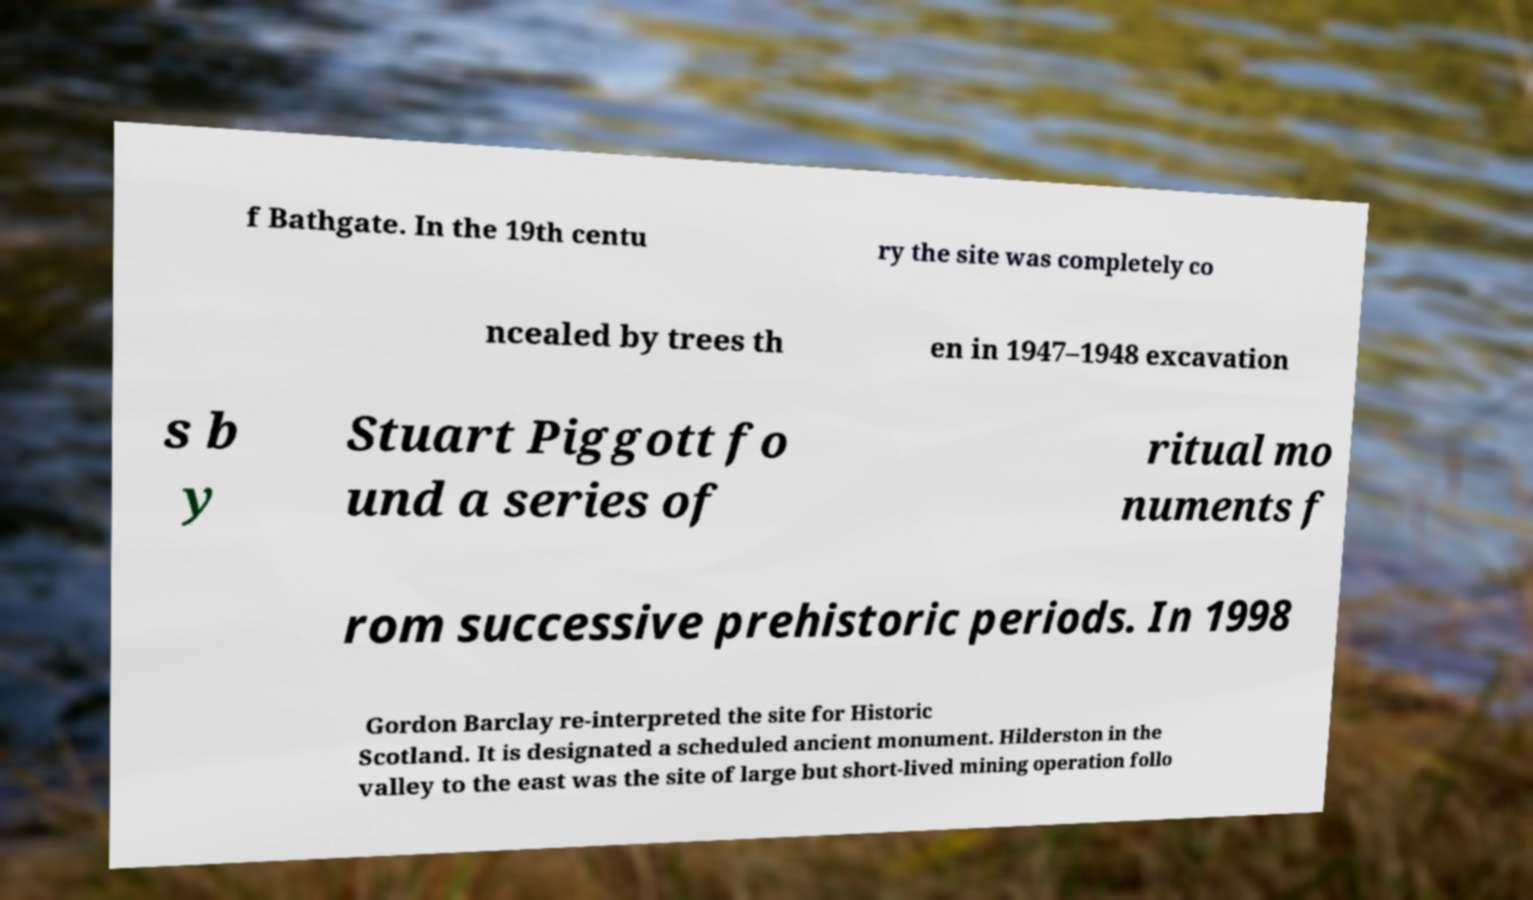Please read and relay the text visible in this image. What does it say? f Bathgate. In the 19th centu ry the site was completely co ncealed by trees th en in 1947–1948 excavation s b y Stuart Piggott fo und a series of ritual mo numents f rom successive prehistoric periods. In 1998 Gordon Barclay re-interpreted the site for Historic Scotland. It is designated a scheduled ancient monument. Hilderston in the valley to the east was the site of large but short-lived mining operation follo 